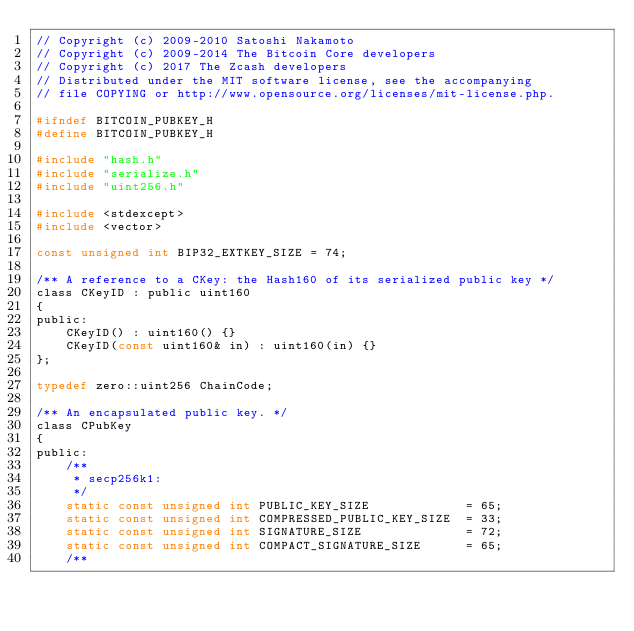<code> <loc_0><loc_0><loc_500><loc_500><_C_>// Copyright (c) 2009-2010 Satoshi Nakamoto
// Copyright (c) 2009-2014 The Bitcoin Core developers
// Copyright (c) 2017 The Zcash developers
// Distributed under the MIT software license, see the accompanying
// file COPYING or http://www.opensource.org/licenses/mit-license.php.

#ifndef BITCOIN_PUBKEY_H
#define BITCOIN_PUBKEY_H

#include "hash.h"
#include "serialize.h"
#include "uint256.h"

#include <stdexcept>
#include <vector>

const unsigned int BIP32_EXTKEY_SIZE = 74;

/** A reference to a CKey: the Hash160 of its serialized public key */
class CKeyID : public uint160
{
public:
    CKeyID() : uint160() {}
    CKeyID(const uint160& in) : uint160(in) {}
};

typedef zero::uint256 ChainCode;

/** An encapsulated public key. */
class CPubKey
{
public:
    /**
     * secp256k1:
     */
    static const unsigned int PUBLIC_KEY_SIZE             = 65;
    static const unsigned int COMPRESSED_PUBLIC_KEY_SIZE  = 33;
    static const unsigned int SIGNATURE_SIZE              = 72;
    static const unsigned int COMPACT_SIGNATURE_SIZE      = 65;
    /**</code> 